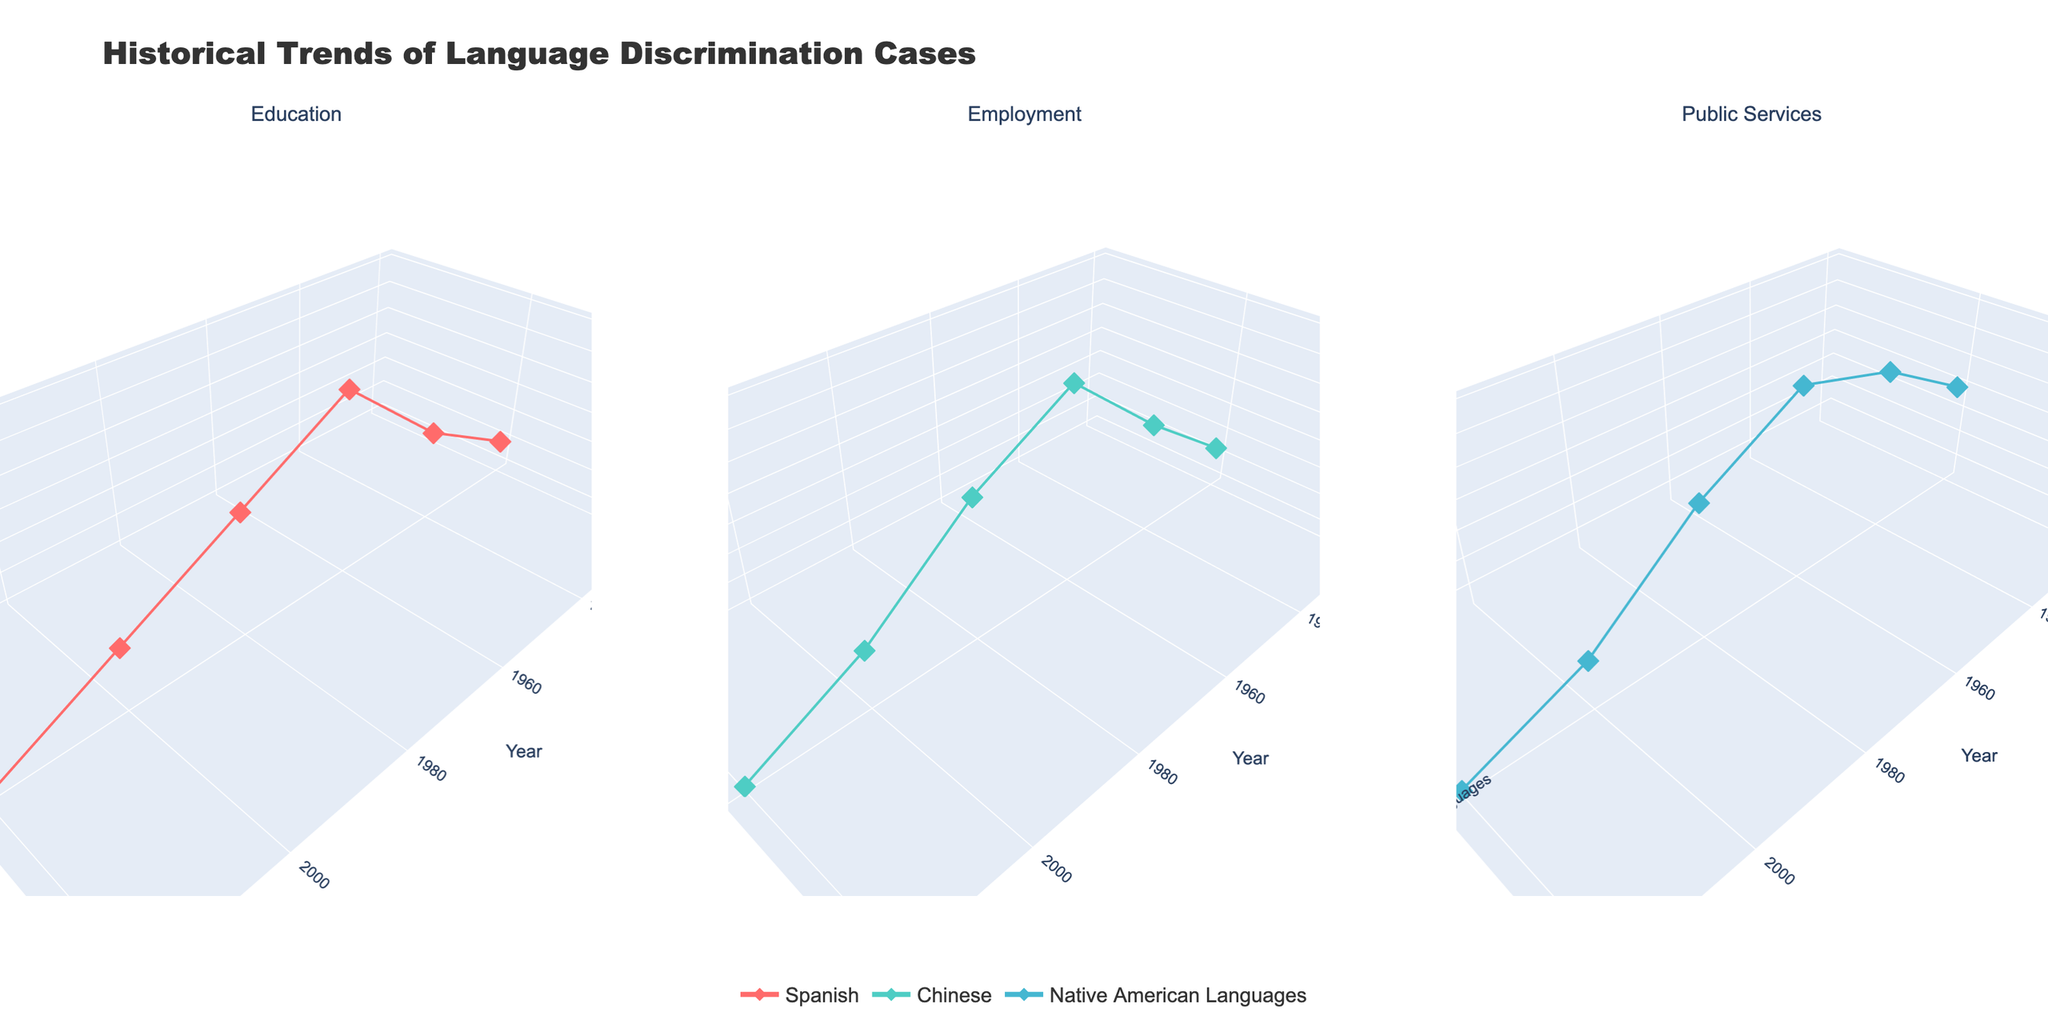What's the title of the figure? The title is usually displayed at the top of the figure. Here it is "Historical Trends of Language Discrimination Cases".
Answer: Historical Trends of Language Discrimination Cases How are the trends of language discrimination cases in education displayed? The trends are shown using markers and lines plotted in a 3D space, representing years on the x-axis, languages on the y-axis, and the number of cases on the z-axis.
Answer: Markers and lines in 3D space Which language had the highest number of discrimination cases in public services in 1960? Look at the public services subplot for the 1960 point on the x-axis. The language with the highest z-axis value (cases) is Native American Languages.
Answer: Native American Languages How did the number of discrimination cases for Spanish change in education from 1940 to 1960? Compare the z-axis values (cases) for Spanish in education between 1940 and 1960. It increased from 25 to 40.
Answer: Increased from 25 to 40 Which domain saw the largest decrease in discrimination cases for Chinese between 1980 and 2000? Compare the z-axis values for Chinese between 1980 and 2000 across all three domains. The largest decrease is in employment, from 40 to 25.
Answer: Employment What is the overall trend for discrimination cases in public services? Observe the line for Native American Languages in the Public Services subplot over time. The trend shows fluctuation but a general decrease from 30 in 1920 to 12 in 2020.
Answer: General decrease Which year saw the peak number of discrimination cases for Spanish in education? Identify the highest z-axis value for Spanish in the education subplot. The peak is in 1960 with 40 cases.
Answer: 1960 Compare the discrimination trends for Chinese in employment and public services. Look at the employment and public services subplots and track the z-axis values over time. Both domains experience a rise until 1960 and then a decline, but the decline in public services is more pronounced.
Answer: Both rise until 1960 and then decline How does the discrimination against Native American Languages in public services in 1940 compare to 1920? Compare the z-axis values for Native American Languages in public services between 1940 and 1920. The cases increased from 30 to 40.
Answer: Increased from 30 to 40 What is the color used to represent the Spanish language in the figure? Colors are used consistently across plots, and Spanish is marked with a specific color. The color is observed to be a reddish hue.
Answer: Reddish hue 